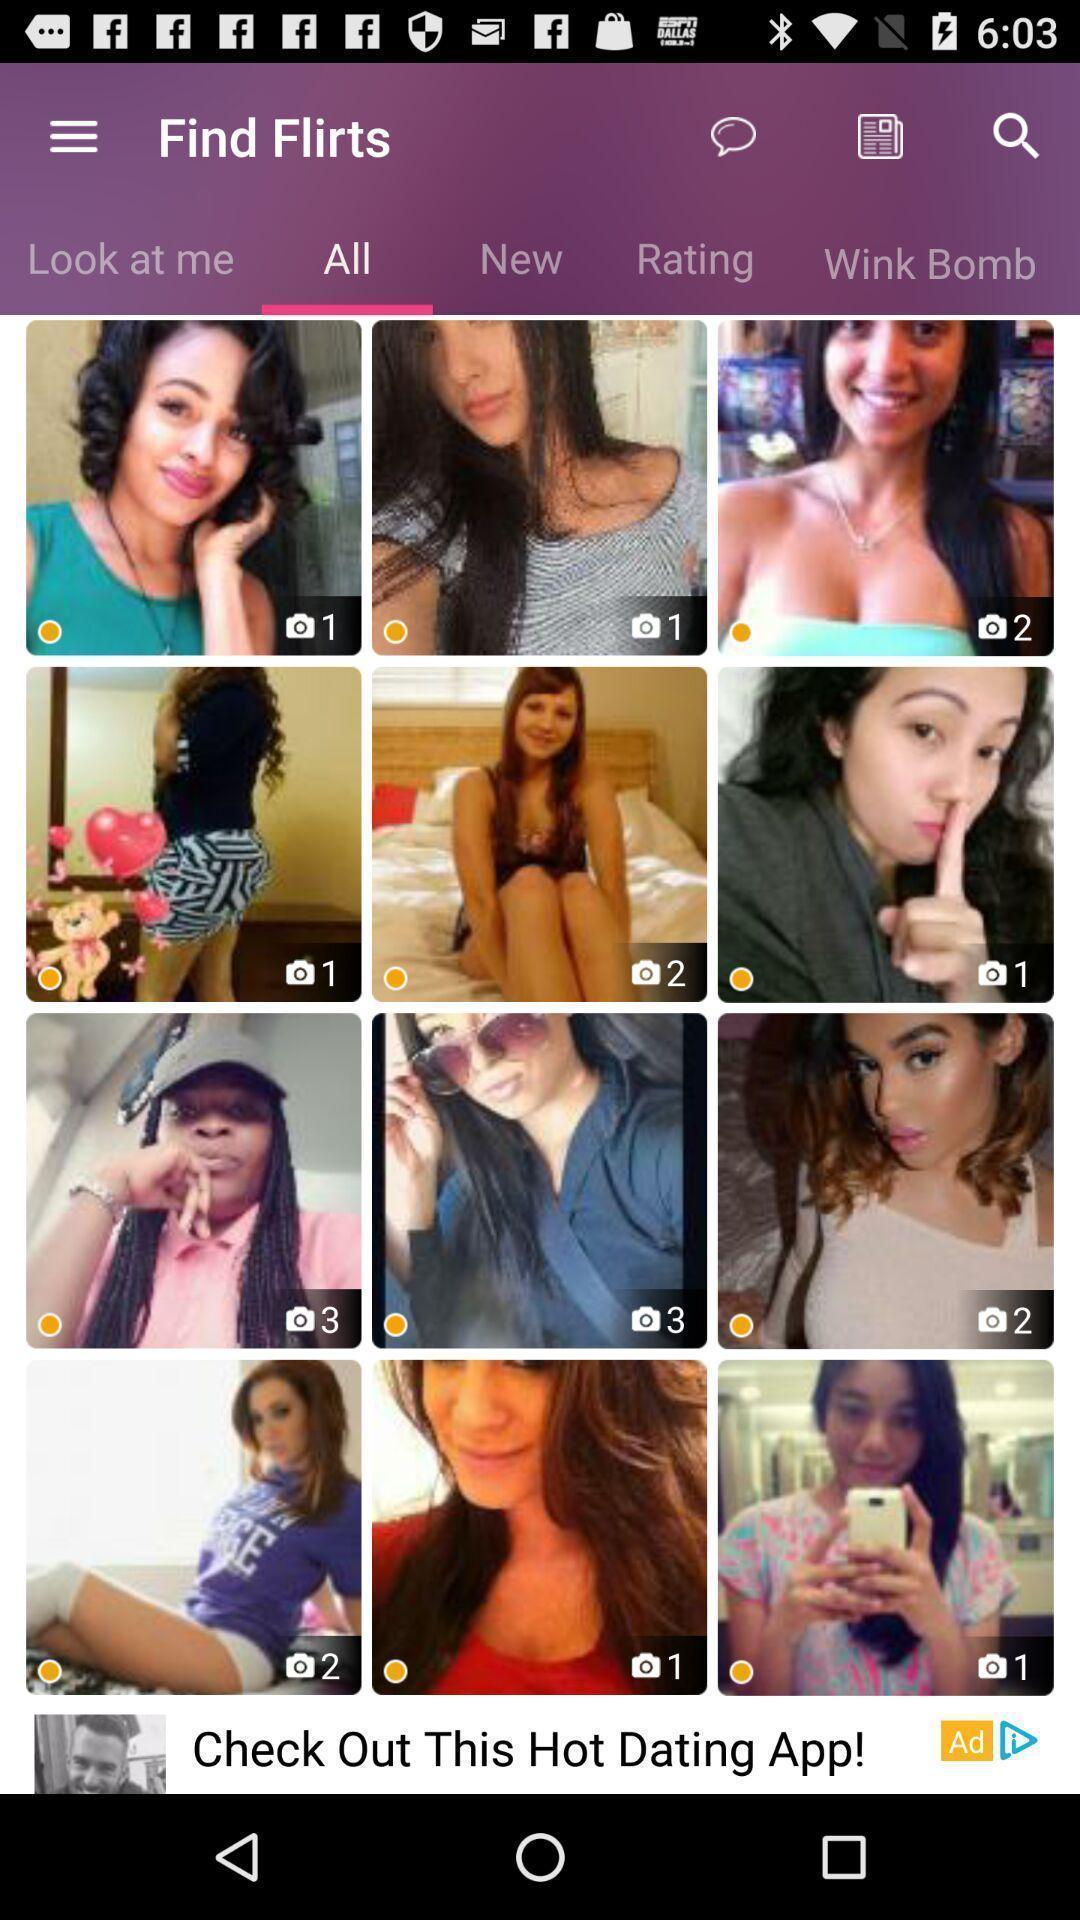Describe the visual elements of this screenshot. Set of photos in a dating app. 